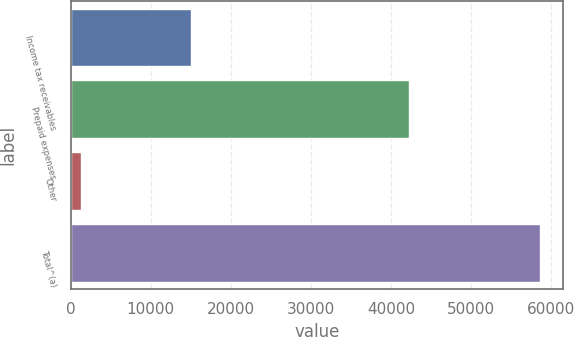<chart> <loc_0><loc_0><loc_500><loc_500><bar_chart><fcel>Income tax receivables<fcel>Prepaid expenses<fcel>Other<fcel>Total^(a)<nl><fcel>15085<fcel>42240<fcel>1254<fcel>58579<nl></chart> 